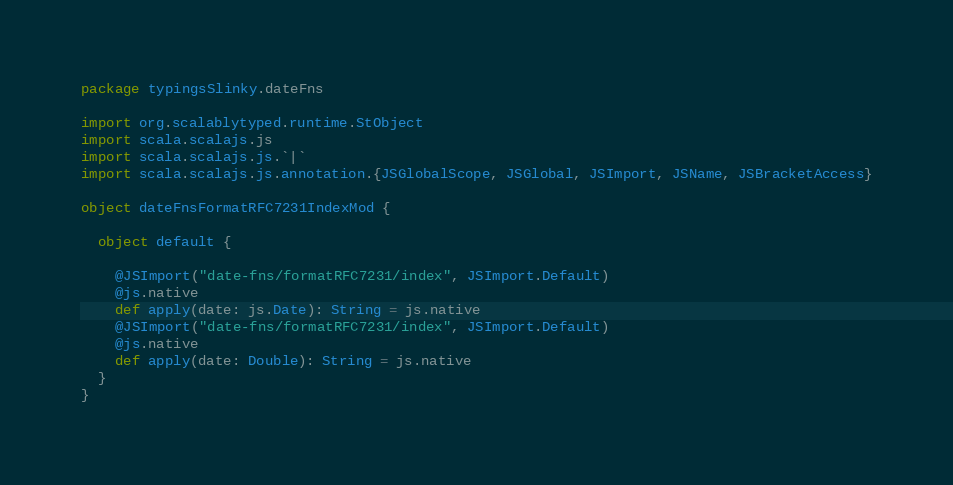<code> <loc_0><loc_0><loc_500><loc_500><_Scala_>package typingsSlinky.dateFns

import org.scalablytyped.runtime.StObject
import scala.scalajs.js
import scala.scalajs.js.`|`
import scala.scalajs.js.annotation.{JSGlobalScope, JSGlobal, JSImport, JSName, JSBracketAccess}

object dateFnsFormatRFC7231IndexMod {
  
  object default {
    
    @JSImport("date-fns/formatRFC7231/index", JSImport.Default)
    @js.native
    def apply(date: js.Date): String = js.native
    @JSImport("date-fns/formatRFC7231/index", JSImport.Default)
    @js.native
    def apply(date: Double): String = js.native
  }
}
</code> 